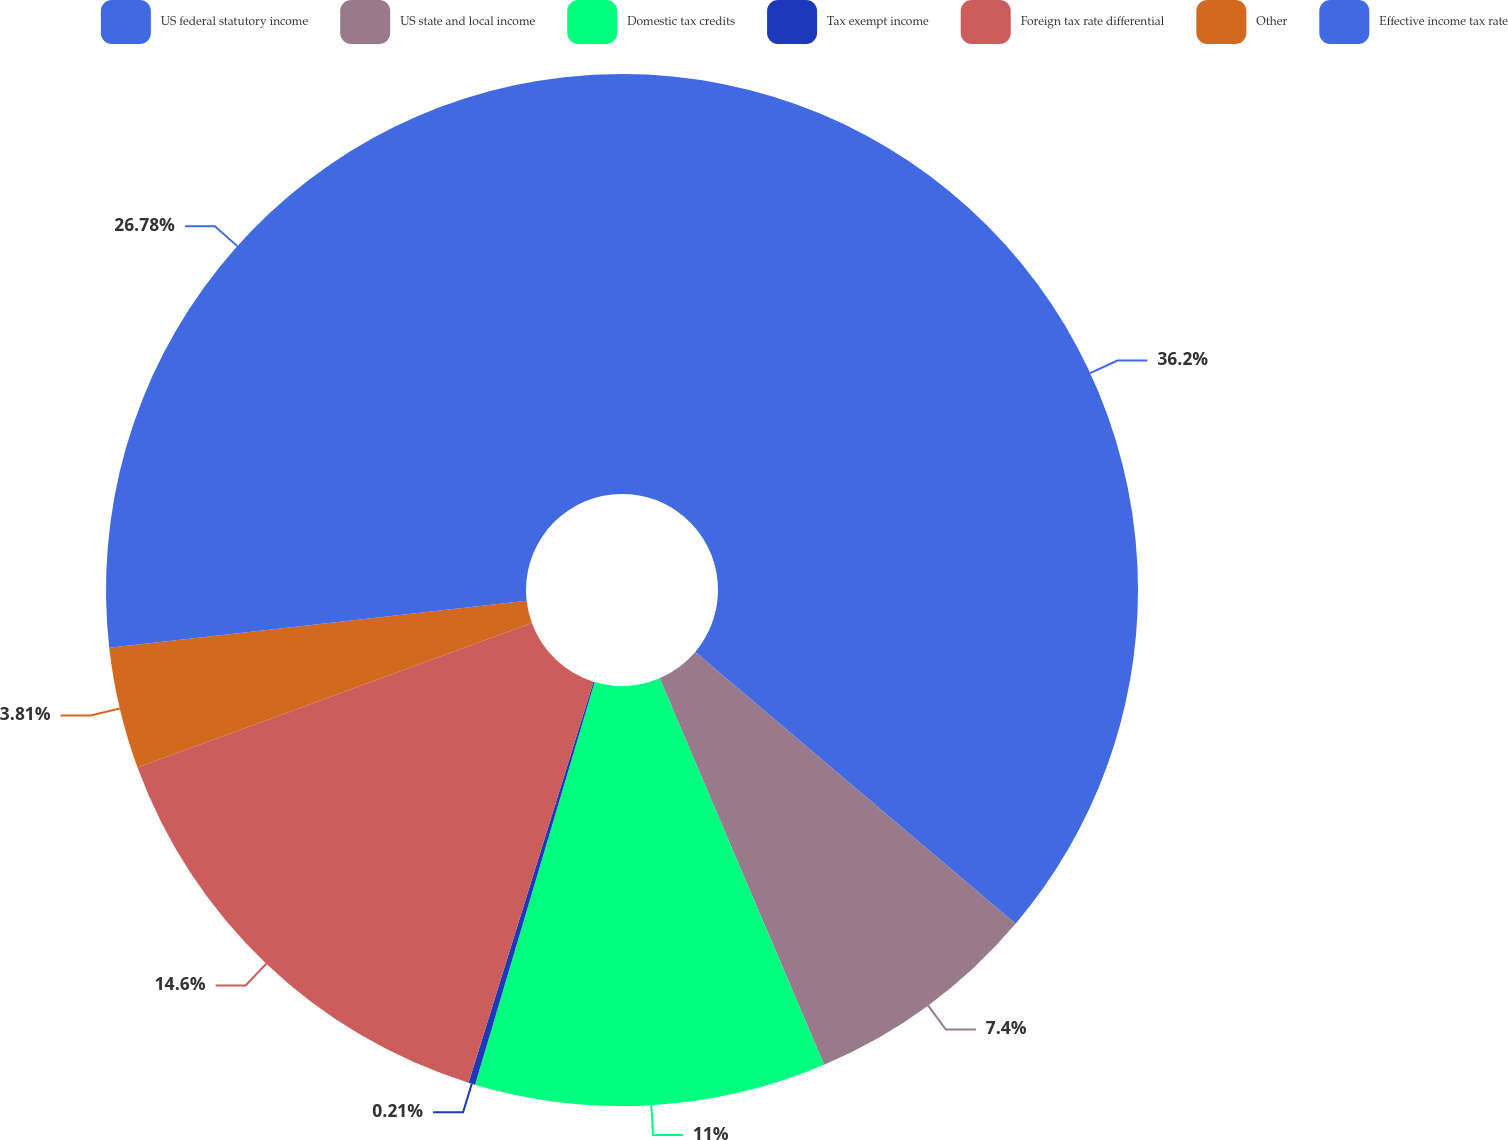<chart> <loc_0><loc_0><loc_500><loc_500><pie_chart><fcel>US federal statutory income<fcel>US state and local income<fcel>Domestic tax credits<fcel>Tax exempt income<fcel>Foreign tax rate differential<fcel>Other<fcel>Effective income tax rate<nl><fcel>36.19%<fcel>7.4%<fcel>11.0%<fcel>0.21%<fcel>14.6%<fcel>3.81%<fcel>26.78%<nl></chart> 